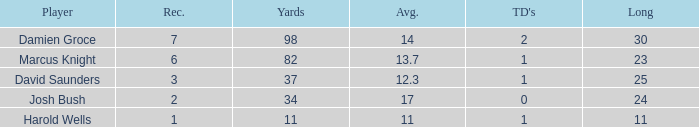What is the number of touchdowns where the distance is less than 23 yards? 1.0. 